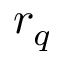<formula> <loc_0><loc_0><loc_500><loc_500>r _ { q }</formula> 